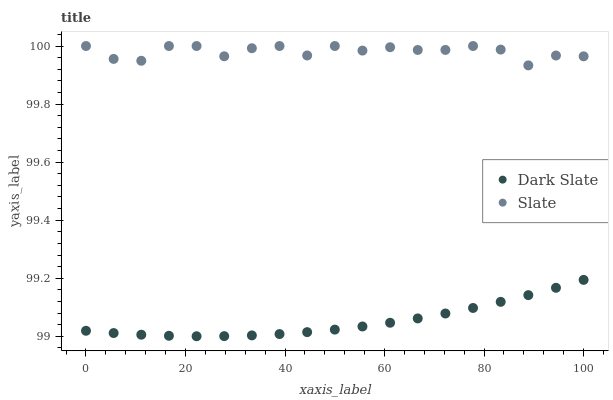Does Dark Slate have the minimum area under the curve?
Answer yes or no. Yes. Does Slate have the maximum area under the curve?
Answer yes or no. Yes. Does Slate have the minimum area under the curve?
Answer yes or no. No. Is Dark Slate the smoothest?
Answer yes or no. Yes. Is Slate the roughest?
Answer yes or no. Yes. Is Slate the smoothest?
Answer yes or no. No. Does Dark Slate have the lowest value?
Answer yes or no. Yes. Does Slate have the lowest value?
Answer yes or no. No. Does Slate have the highest value?
Answer yes or no. Yes. Is Dark Slate less than Slate?
Answer yes or no. Yes. Is Slate greater than Dark Slate?
Answer yes or no. Yes. Does Dark Slate intersect Slate?
Answer yes or no. No. 